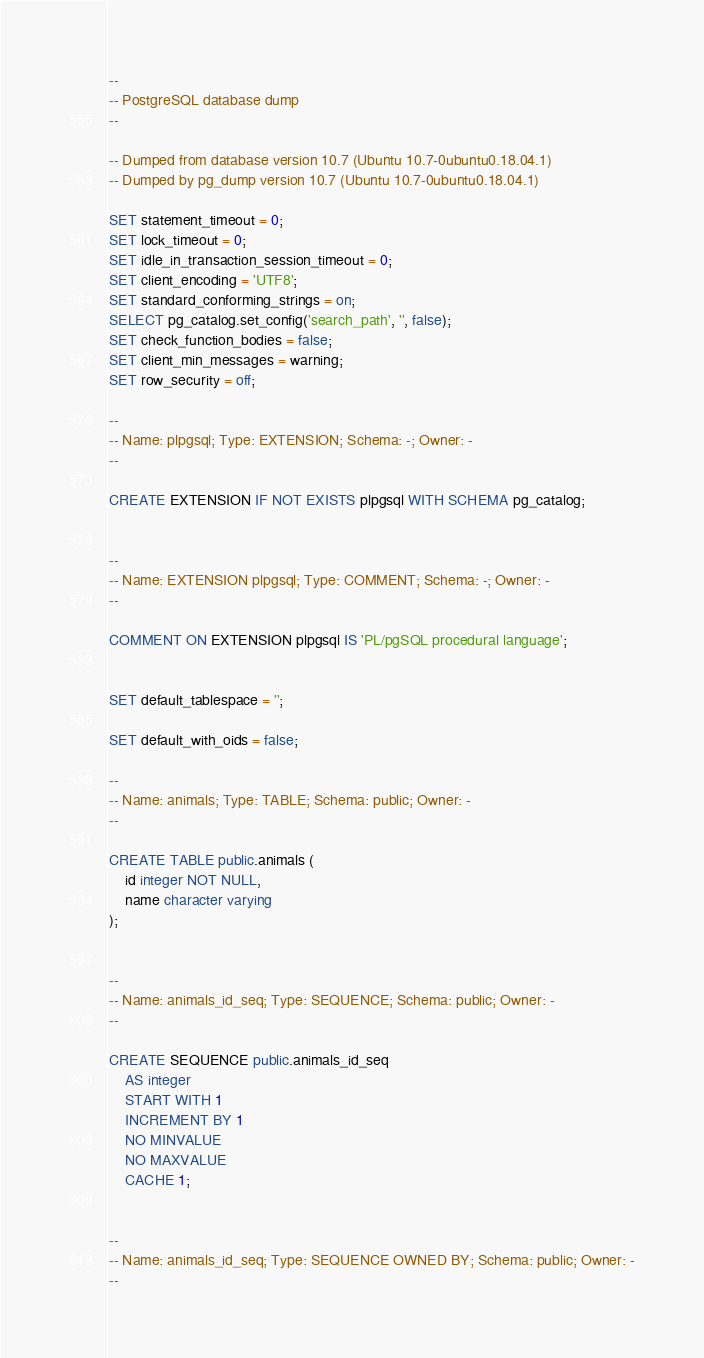Convert code to text. <code><loc_0><loc_0><loc_500><loc_500><_SQL_>--
-- PostgreSQL database dump
--

-- Dumped from database version 10.7 (Ubuntu 10.7-0ubuntu0.18.04.1)
-- Dumped by pg_dump version 10.7 (Ubuntu 10.7-0ubuntu0.18.04.1)

SET statement_timeout = 0;
SET lock_timeout = 0;
SET idle_in_transaction_session_timeout = 0;
SET client_encoding = 'UTF8';
SET standard_conforming_strings = on;
SELECT pg_catalog.set_config('search_path', '', false);
SET check_function_bodies = false;
SET client_min_messages = warning;
SET row_security = off;

--
-- Name: plpgsql; Type: EXTENSION; Schema: -; Owner: -
--

CREATE EXTENSION IF NOT EXISTS plpgsql WITH SCHEMA pg_catalog;


--
-- Name: EXTENSION plpgsql; Type: COMMENT; Schema: -; Owner: -
--

COMMENT ON EXTENSION plpgsql IS 'PL/pgSQL procedural language';


SET default_tablespace = '';

SET default_with_oids = false;

--
-- Name: animals; Type: TABLE; Schema: public; Owner: -
--

CREATE TABLE public.animals (
    id integer NOT NULL,
    name character varying
);


--
-- Name: animals_id_seq; Type: SEQUENCE; Schema: public; Owner: -
--

CREATE SEQUENCE public.animals_id_seq
    AS integer
    START WITH 1
    INCREMENT BY 1
    NO MINVALUE
    NO MAXVALUE
    CACHE 1;


--
-- Name: animals_id_seq; Type: SEQUENCE OWNED BY; Schema: public; Owner: -
--
</code> 